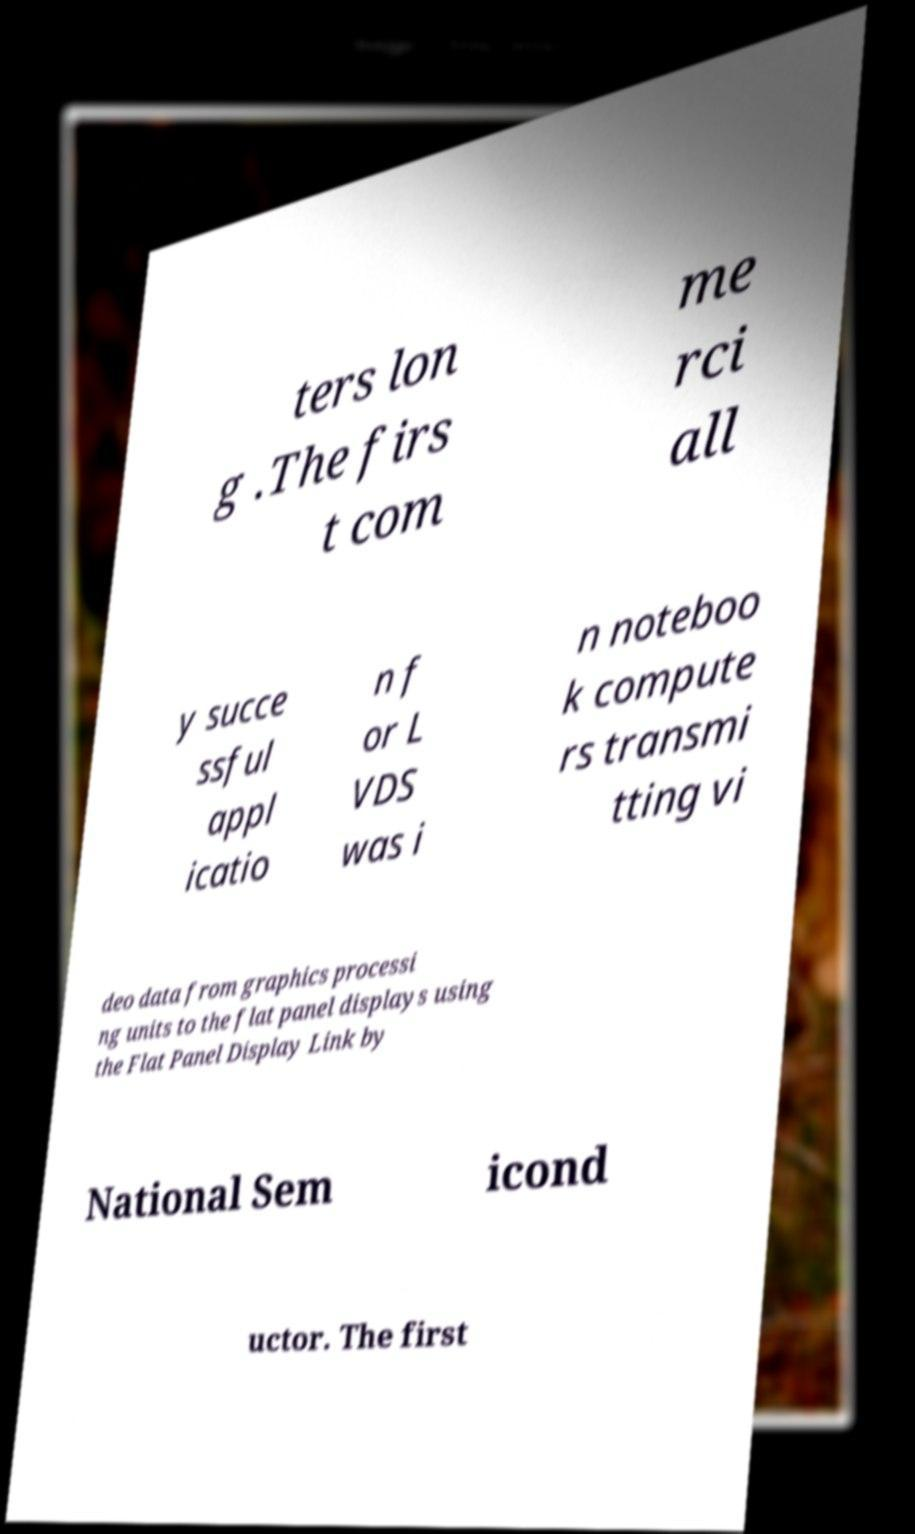There's text embedded in this image that I need extracted. Can you transcribe it verbatim? ters lon g .The firs t com me rci all y succe ssful appl icatio n f or L VDS was i n noteboo k compute rs transmi tting vi deo data from graphics processi ng units to the flat panel displays using the Flat Panel Display Link by National Sem icond uctor. The first 